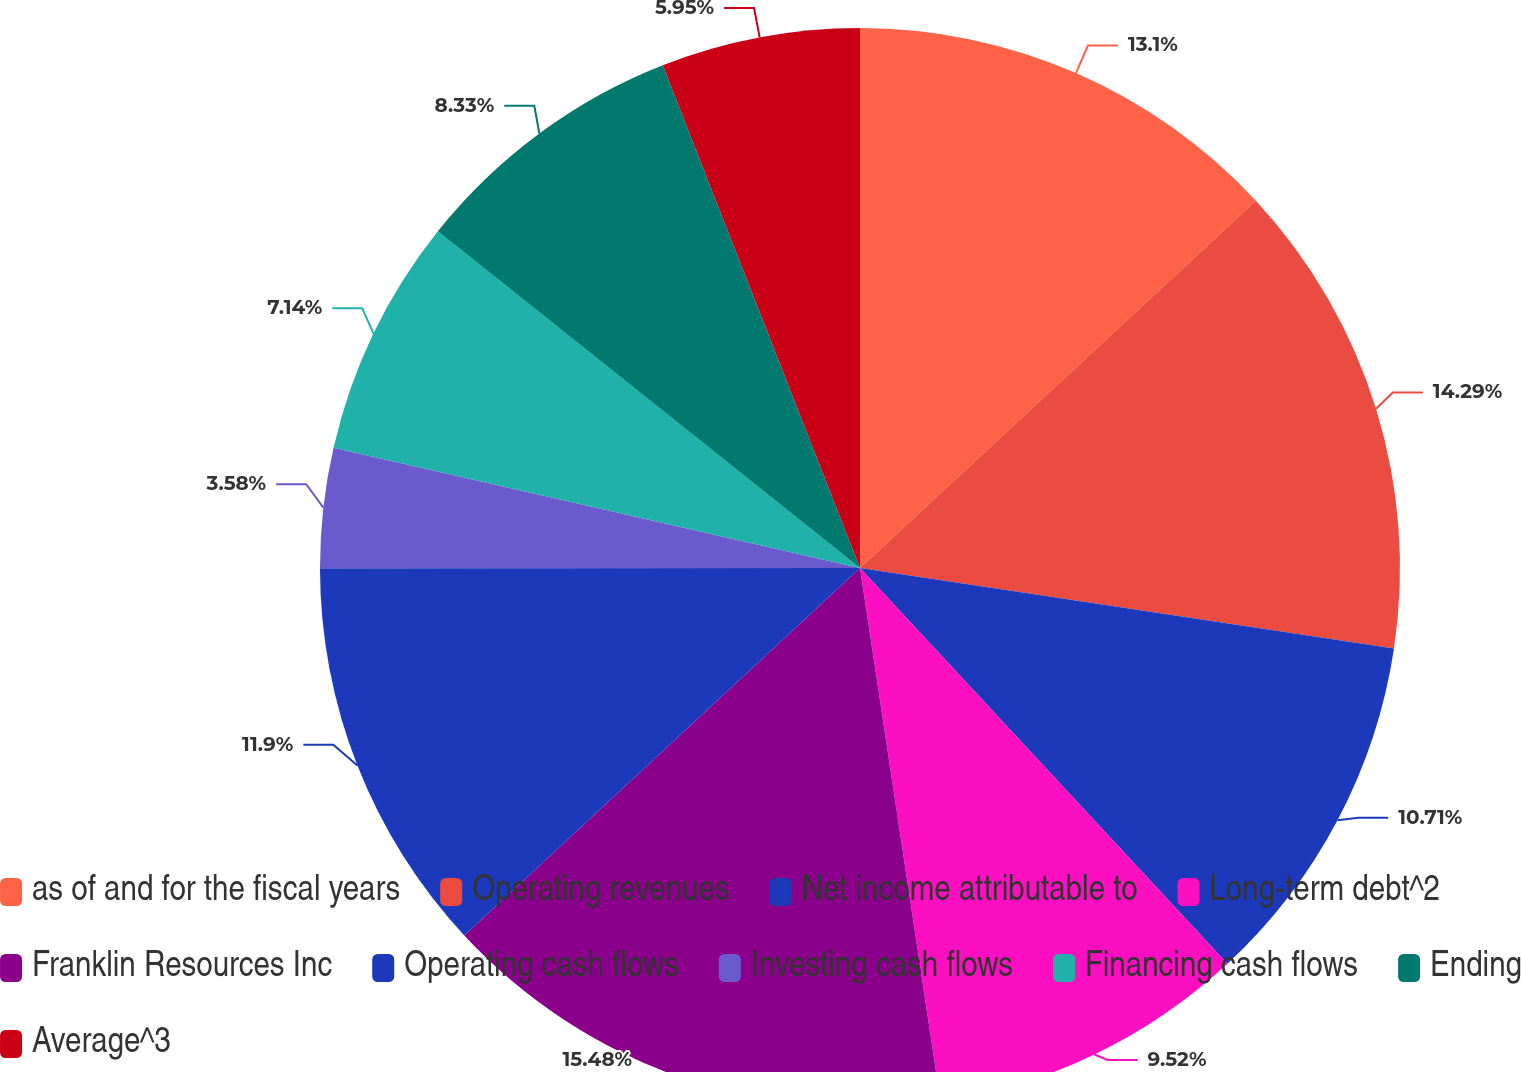<chart> <loc_0><loc_0><loc_500><loc_500><pie_chart><fcel>as of and for the fiscal years<fcel>Operating revenues<fcel>Net income attributable to<fcel>Long-term debt^2<fcel>Franklin Resources Inc<fcel>Operating cash flows<fcel>Investing cash flows<fcel>Financing cash flows<fcel>Ending<fcel>Average^3<nl><fcel>13.09%<fcel>14.28%<fcel>10.71%<fcel>9.52%<fcel>15.47%<fcel>11.9%<fcel>3.58%<fcel>7.14%<fcel>8.33%<fcel>5.95%<nl></chart> 